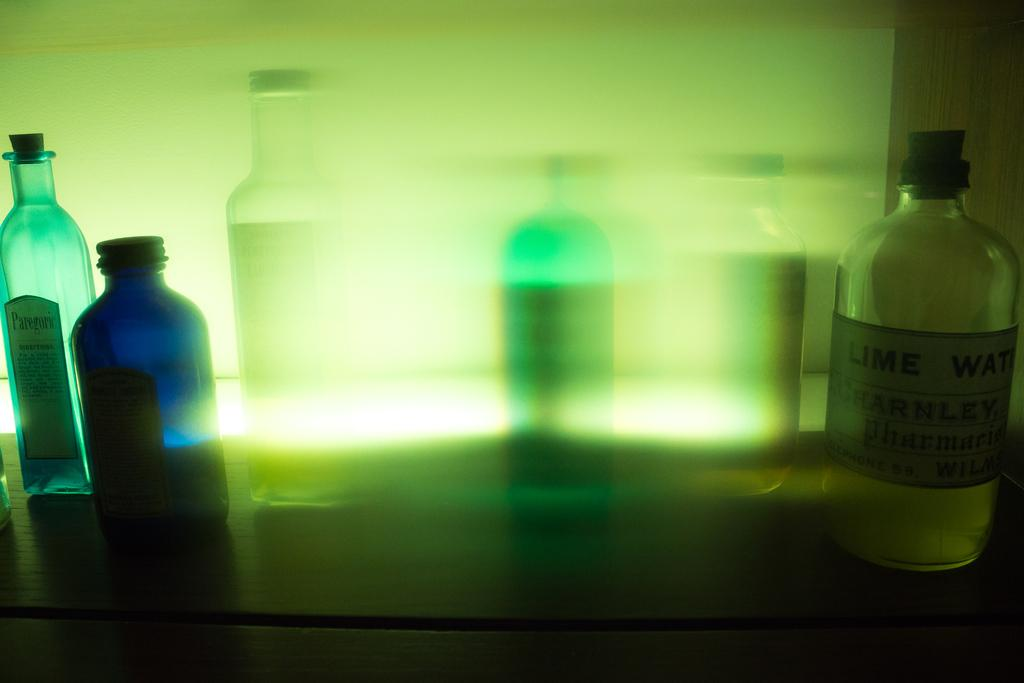What objects are on the table in the image? There are bottles on the table in the image. How many stars can be seen on the cactus in the image? There is no cactus or stars present in the image; it only features bottles on a table. 